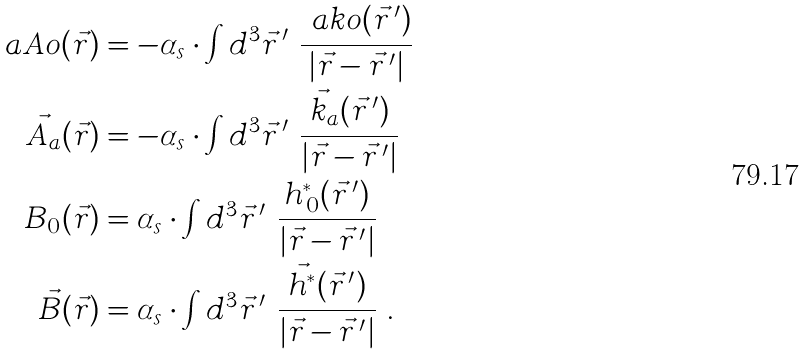Convert formula to latex. <formula><loc_0><loc_0><loc_500><loc_500>\ a A o ( \vec { r } ) & = - \alpha _ { s } \cdot \int d ^ { 3 } \vec { r } \, ^ { \prime } \ \frac { \ a k o ( \vec { r } \, ^ { \prime } ) } { | \vec { r } - \vec { r } \, ^ { \prime } | } \\ \vec { A } _ { a } ( \vec { r } ) & = - \alpha _ { s } \cdot \int d ^ { 3 } \vec { r } \, ^ { \prime } \ \frac { \vec { k } _ { a } ( \vec { r } \, ^ { \prime } ) } { | \vec { r } - \vec { r } \, ^ { \prime } | } \\ B _ { 0 } ( \vec { r } ) & = \alpha _ { s } \cdot \int d ^ { 3 } \vec { r } \, ^ { \prime } \ \frac { h ^ { \ast } _ { \, 0 } ( \vec { r } \, ^ { \prime } ) } { | \vec { r } - \vec { r } \, ^ { \prime } | } \\ \vec { B } ( \vec { r } ) & = \alpha _ { s } \cdot \int d ^ { 3 } \vec { r } \, ^ { \prime } \ \frac { \vec { h } ^ { \ast } ( \vec { r } \, ^ { \prime } ) } { | \vec { r } - \vec { r } \, ^ { \prime } | } \ .</formula> 